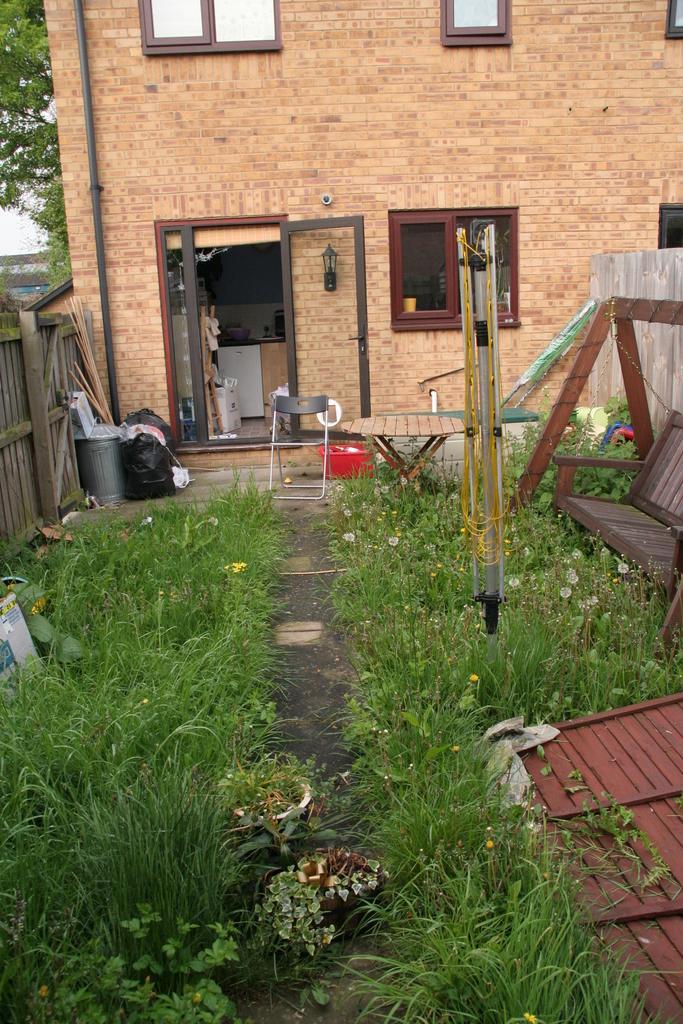Could you give a brief overview of what you see in this image? At the bottom of the picture, we see grass and herbs. On the right side, we see a bench and a brown color railing like. We even see a thing which looks like a pole. Behind that, we see a table, chair and a red color tub. On the left side, we see a plastic cover and a grey color tin. Beside that, we see a wooden fence. In the background, we see a building and trees. This building has doors and windows. 